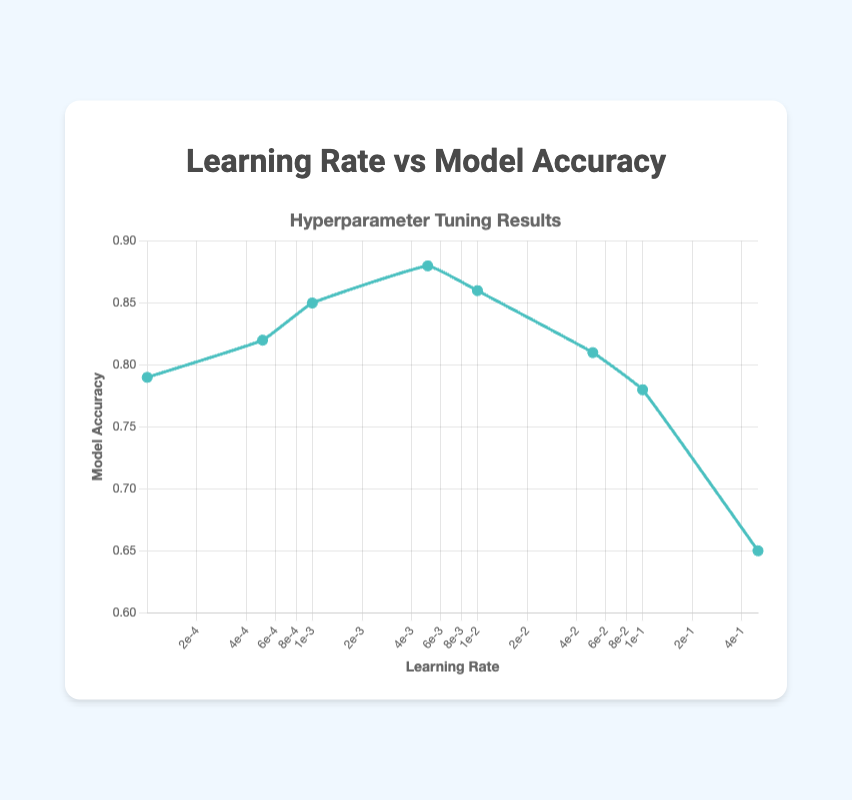What is the trend of model accuracy as the learning rate increases? The model accuracy increases until the learning rate reaches 0.005, then it begins to decrease as the learning rate continues to rise. Initially, lower learning rates show increased accuracy, peaking at 0.005, and then accuracy drops with higher learning rates.
Answer: Model accuracy initially increases, peaks at 0.005, then decreases What is the highest recorded model accuracy, and at which learning rate does it occur? The highest model accuracy is found by looking at all the data points. The value 0.88 (model accuracy) is the maximum, and it occurs at a learning rate of 0.005.
Answer: 0.88 at 0.005 learning rate Which learning rate results in the lowest model accuracy? By comparing all the data points, the learning rate of 0.5 results in the lowest model accuracy of 0.65.
Answer: 0.5 learning rate At which learning rate(s) does the model accuracy drop below 0.8? By scanning through the data points, observed that learning rates of 0.0001, 0.05, 0.1, and 0.5 result in model accuracies of 0.79, 0.81, 0.78, and 0.65 respectively, with only 0.1 and 0.5 below 0.8.
Answer: 0.1 and 0.5 learning rates How does the accuracy at a learning rate of 0.01 compare to that at 0.005? Observe the model accuracy for learning rates 0.01 (0.86) and 0.005 (0.88). Accuracy at 0.01 is slightly lower than at 0.005.
Answer: Slightly lower What is the average model accuracy for all learning rates below 0.01? Only consider learning rates below 0.01: 0.0001 (0.79), 0.0005 (0.82), 0.001 (0.85), and 0.005 (0.88). Compute the average: (0.79 + 0.82 + 0.85 + 0.88) / 4 = 3.34 / 4 = 0.835.
Answer: 0.835 What is the difference in model accuracy between the highest learning rate and the lowest learning rate? Find model accuracies at the highest (0.5) and lowest (0.0001) learning rates, which are 0.65 and 0.79 respectively. The difference is 0.79 - 0.65 = 0.14.
Answer: 0.14 Between the learning rate of 0.05 and 0.5, which exhibits a more significant drop in accuracy compared to 0.005? Compare drops in accuracy from the peak value at 0.005 (accuracy 0.88). For 0.05 (0.81), drop is 0.88 - 0.81 = 0.07. For 0.5 (0.65), drop is 0.88 - 0.65 = 0.23. The drop at 0.5 is larger.
Answer: 0.5 exhibits a larger drop Which range of learning rates shows the steepest decline in accuracy? Evaluate the differences in accuracy: 0.01 to 0.05 (0.86 - 0.81 = 0.05), 0.05 to 0.1 (0.81 - 0.78 = 0.03), and 0.1 to 0.5 (0.78 - 0.65 = 0.13). The steepest decline, 0.13, occurs between 0.1 and 0.5.
Answer: Between 0.1 and 0.5 